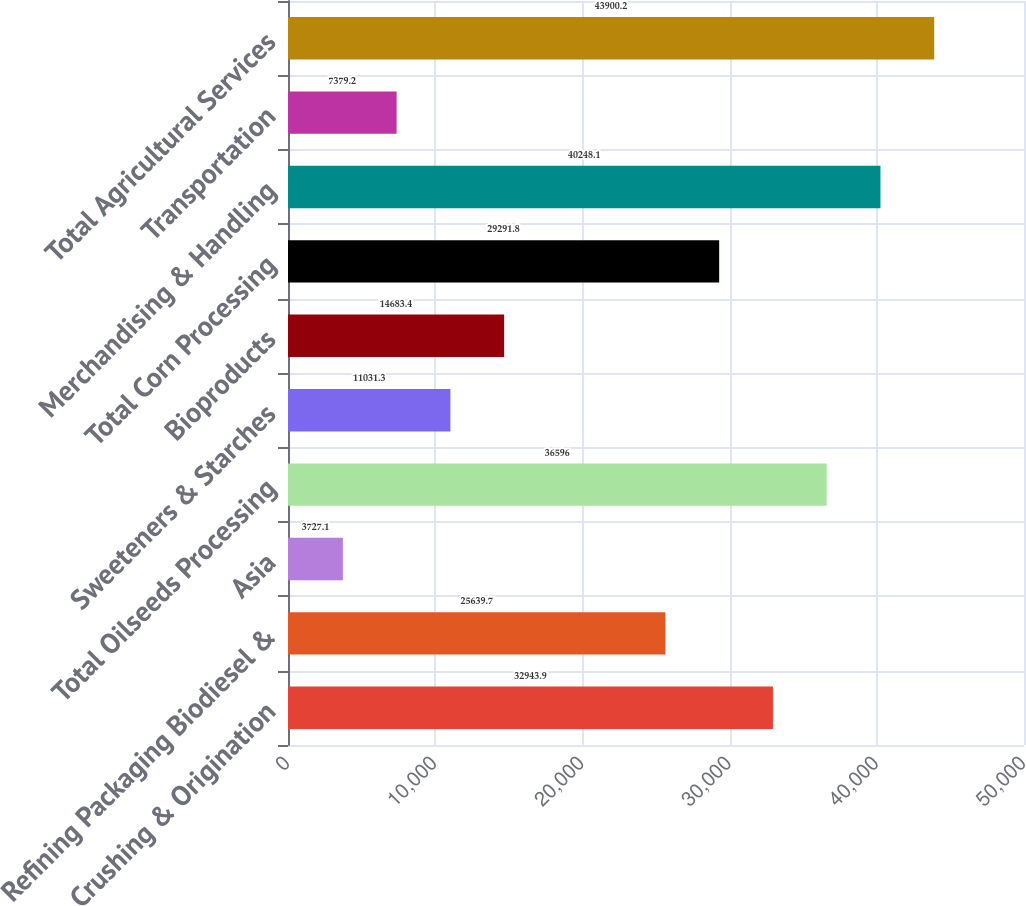Convert chart. <chart><loc_0><loc_0><loc_500><loc_500><bar_chart><fcel>Crushing & Origination<fcel>Refining Packaging Biodiesel &<fcel>Asia<fcel>Total Oilseeds Processing<fcel>Sweeteners & Starches<fcel>Bioproducts<fcel>Total Corn Processing<fcel>Merchandising & Handling<fcel>Transportation<fcel>Total Agricultural Services<nl><fcel>32943.9<fcel>25639.7<fcel>3727.1<fcel>36596<fcel>11031.3<fcel>14683.4<fcel>29291.8<fcel>40248.1<fcel>7379.2<fcel>43900.2<nl></chart> 